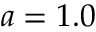<formula> <loc_0><loc_0><loc_500><loc_500>a = 1 . 0</formula> 